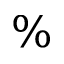Convert formula to latex. <formula><loc_0><loc_0><loc_500><loc_500>\%</formula> 